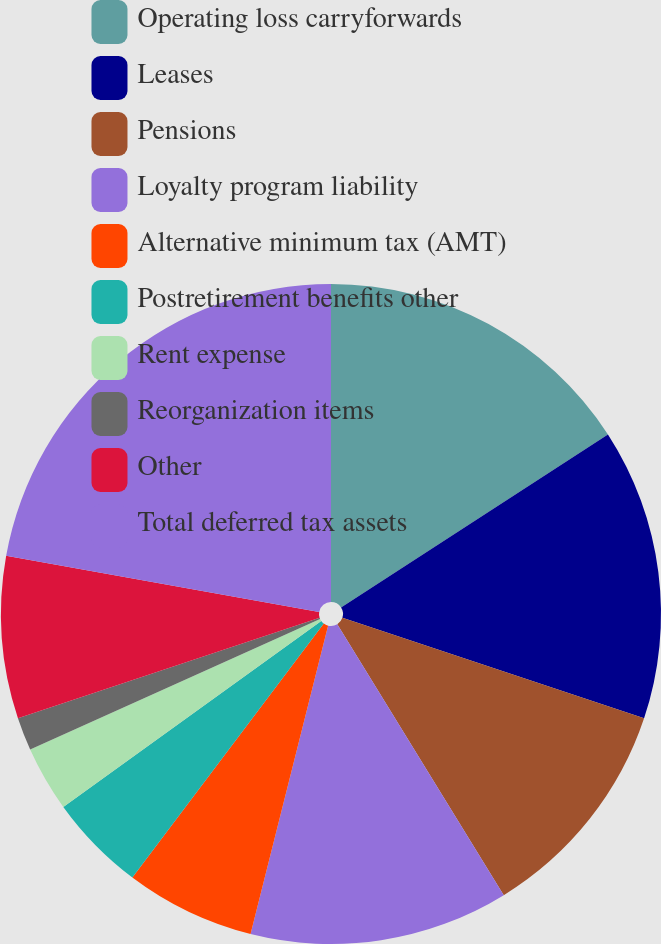Convert chart. <chart><loc_0><loc_0><loc_500><loc_500><pie_chart><fcel>Operating loss carryforwards<fcel>Leases<fcel>Pensions<fcel>Loyalty program liability<fcel>Alternative minimum tax (AMT)<fcel>Postretirement benefits other<fcel>Rent expense<fcel>Reorganization items<fcel>Other<fcel>Total deferred tax assets<nl><fcel>15.85%<fcel>14.27%<fcel>11.11%<fcel>12.69%<fcel>6.36%<fcel>4.78%<fcel>3.2%<fcel>1.62%<fcel>7.94%<fcel>22.18%<nl></chart> 